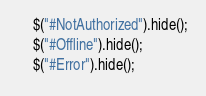<code> <loc_0><loc_0><loc_500><loc_500><_JavaScript_>	$("#NotAuthorized").hide();
	$("#Offline").hide();
	$("#Error").hide();</code> 